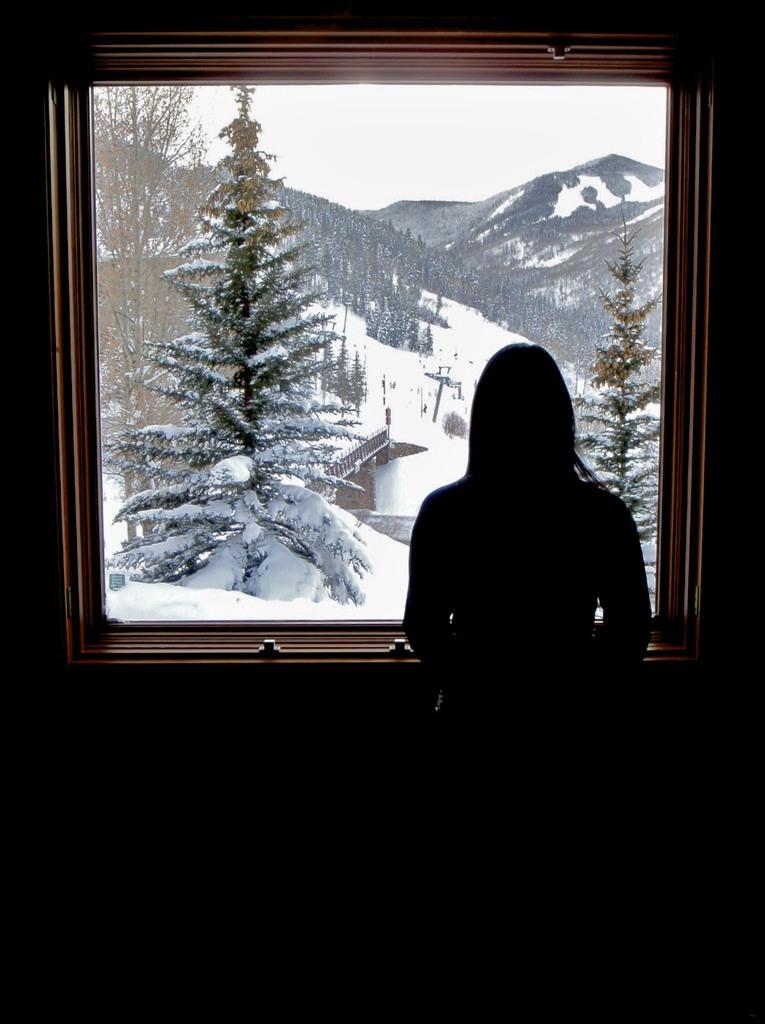What is the woman doing in the image? The woman is standing near a window. What can be seen through the window? Trees, hills, and the sky are visible through the window. What is the overall appearance of the scene? The scene is covered with snow. How many fans are visible in the image? There are no fans present in the image. Are the woman's brothers also visible in the image? There is no mention of the woman having brothers or any other people in the image. 